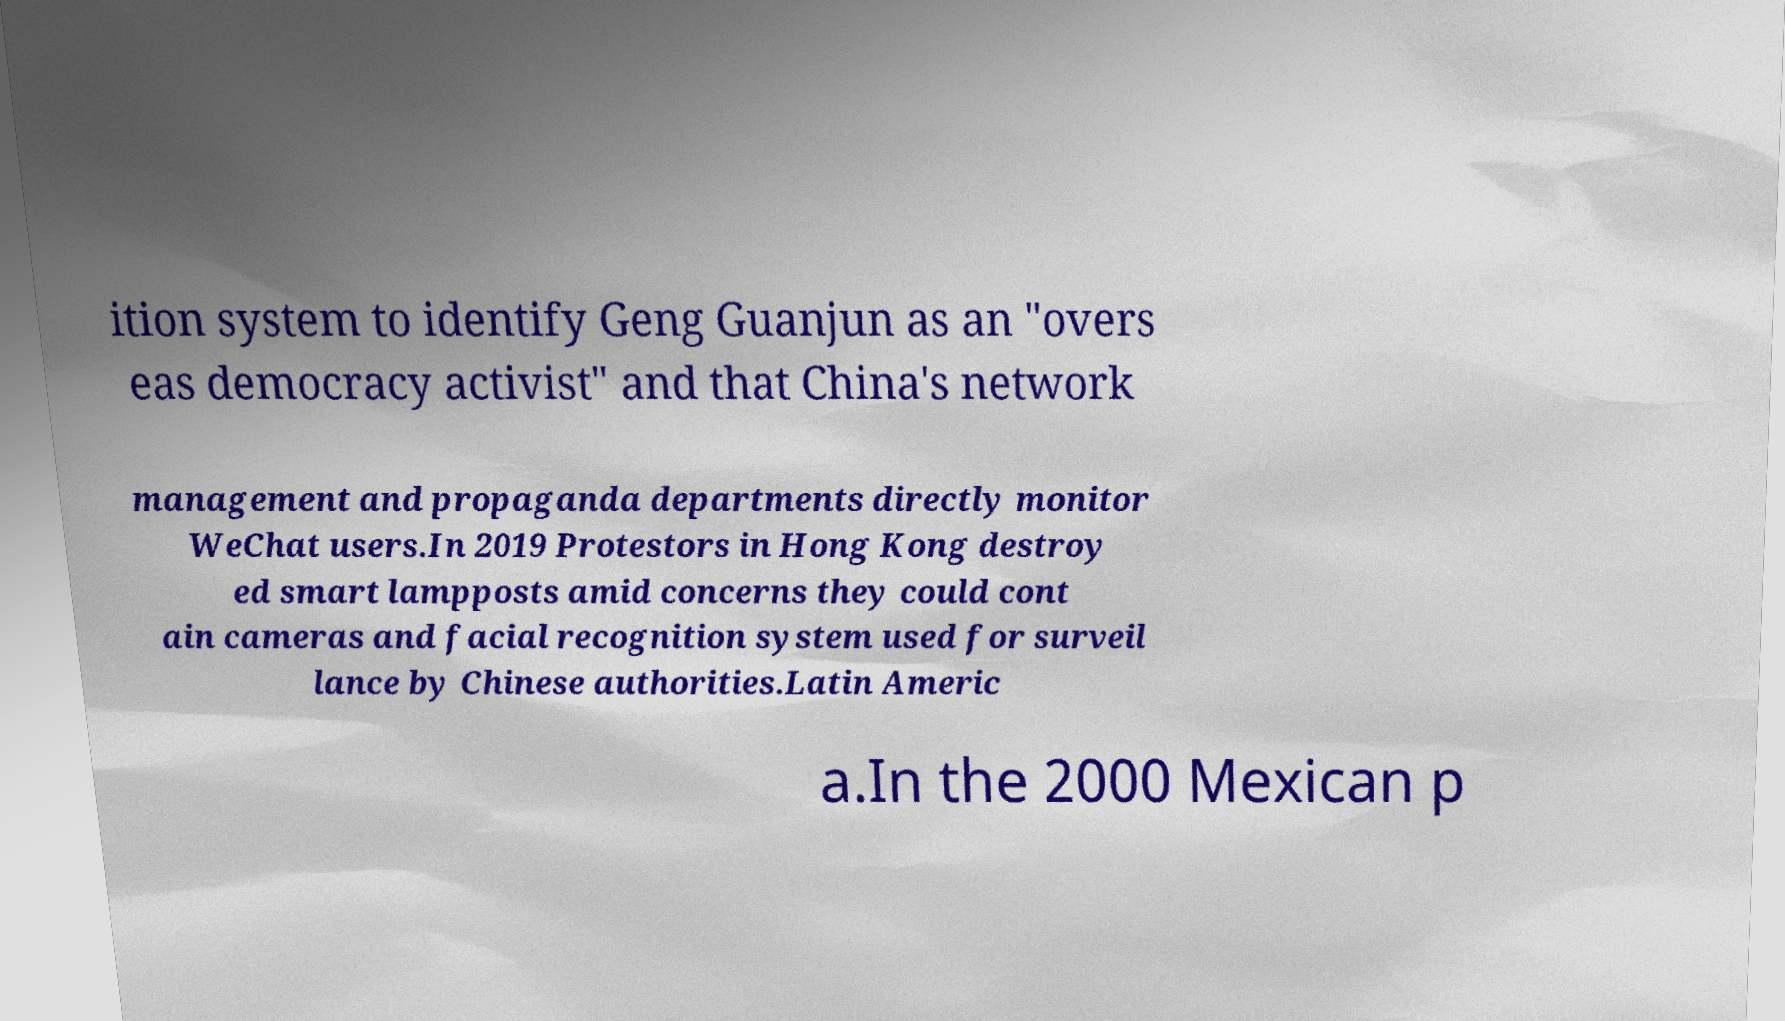There's text embedded in this image that I need extracted. Can you transcribe it verbatim? ition system to identify Geng Guanjun as an "overs eas democracy activist" and that China's network management and propaganda departments directly monitor WeChat users.In 2019 Protestors in Hong Kong destroy ed smart lampposts amid concerns they could cont ain cameras and facial recognition system used for surveil lance by Chinese authorities.Latin Americ a.In the 2000 Mexican p 